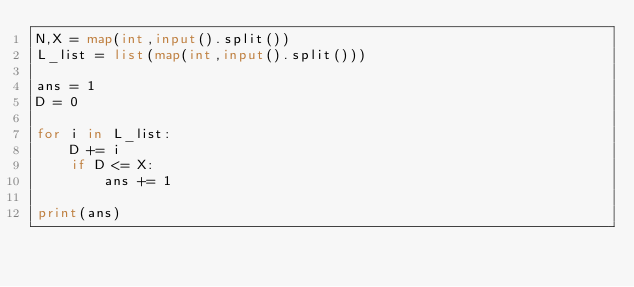Convert code to text. <code><loc_0><loc_0><loc_500><loc_500><_Python_>N,X = map(int,input().split())
L_list = list(map(int,input().split()))

ans = 1
D = 0

for i in L_list:
    D += i
    if D <= X:
        ans += 1

print(ans)</code> 